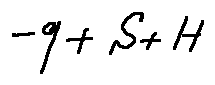Convert formula to latex. <formula><loc_0><loc_0><loc_500><loc_500>- q - S + H</formula> 